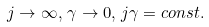<formula> <loc_0><loc_0><loc_500><loc_500>j \rightarrow \infty , \, \gamma \rightarrow 0 , \, j \gamma = c o n s t .</formula> 